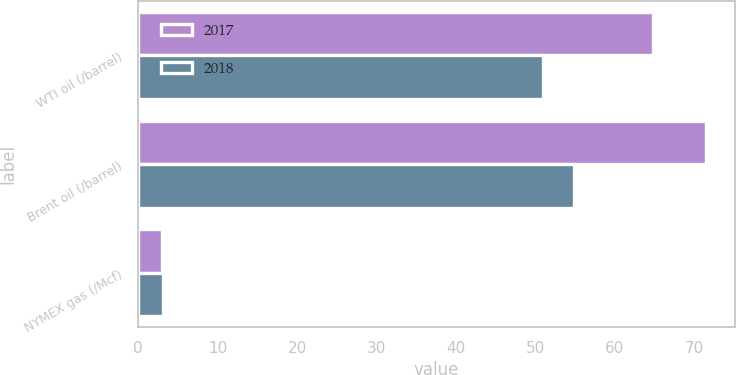Convert chart. <chart><loc_0><loc_0><loc_500><loc_500><stacked_bar_chart><ecel><fcel>WTI oil (/barrel)<fcel>Brent oil (/barrel)<fcel>NYMEX gas (/Mcf)<nl><fcel>2017<fcel>64.77<fcel>71.53<fcel>2.97<nl><fcel>2018<fcel>50.95<fcel>54.82<fcel>3.09<nl></chart> 